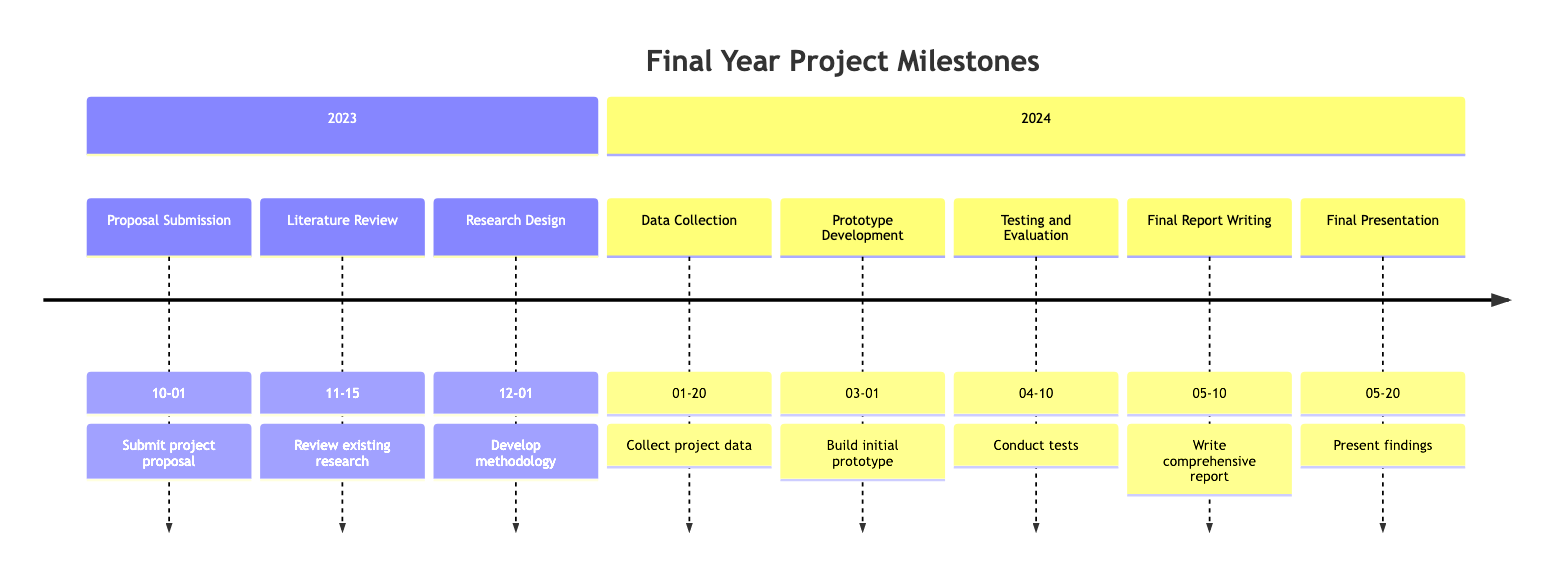What is the deadline for the Proposal Submission? The diagram indicates that the Proposal Submission is due on October 1, 2023.
Answer: October 1, 2023 How many milestones are in the 2023 section? The 2023 section contains three milestones: Proposal Submission, Literature Review, and Research Design.
Answer: 3 What stage follows the Literature Review? Following the Literature Review, the next stage is Research Design according to the timeline.
Answer: Research Design What is the final stage in the timeline for 2024? The final stage in the timeline for 2024 is the Final Presentation scheduled for May 20, 2024.
Answer: Final Presentation When is the Data Collection deadline? The Data Collection milestone has a deadline of January 20, 2024.
Answer: January 20, 2024 How many days are between the Prototype Development and Final Report Writing deadlines? The Prototype Development is due on March 1, 2024, and the Final Report Writing is due on May 10, 2024. This equates to 70 days between these two deadlines.
Answer: 70 days What is the description for the Testing and Evaluation stage? The Testing and Evaluation stage is defined as conducting tests on the prototype and evaluating its performance.
Answer: Conduct tests on the prototype and evaluate its performance Name the first milestone of 2024. The first milestone in 2024 is Data Collection, which is indicated in the timeline.
Answer: Data Collection Which two milestones occur in April 2024? The two milestones that take place in April 2024 are Testing and Evaluation on April 10 and the Final Report Writing on May 10.
Answer: Testing and Evaluation, Final Report Writing 